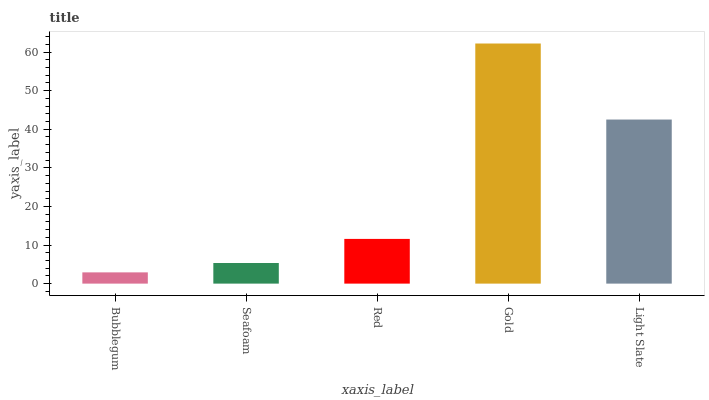Is Seafoam the minimum?
Answer yes or no. No. Is Seafoam the maximum?
Answer yes or no. No. Is Seafoam greater than Bubblegum?
Answer yes or no. Yes. Is Bubblegum less than Seafoam?
Answer yes or no. Yes. Is Bubblegum greater than Seafoam?
Answer yes or no. No. Is Seafoam less than Bubblegum?
Answer yes or no. No. Is Red the high median?
Answer yes or no. Yes. Is Red the low median?
Answer yes or no. Yes. Is Seafoam the high median?
Answer yes or no. No. Is Light Slate the low median?
Answer yes or no. No. 